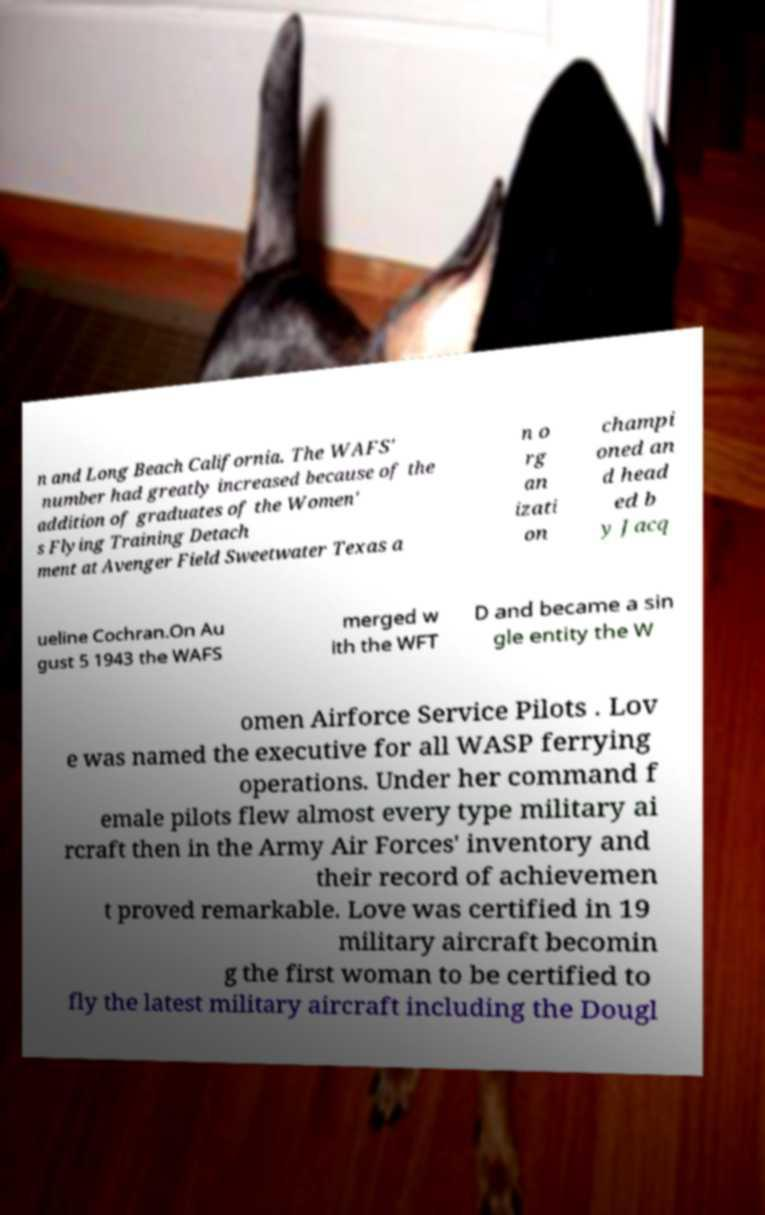There's text embedded in this image that I need extracted. Can you transcribe it verbatim? n and Long Beach California. The WAFS' number had greatly increased because of the addition of graduates of the Women' s Flying Training Detach ment at Avenger Field Sweetwater Texas a n o rg an izati on champi oned an d head ed b y Jacq ueline Cochran.On Au gust 5 1943 the WAFS merged w ith the WFT D and became a sin gle entity the W omen Airforce Service Pilots . Lov e was named the executive for all WASP ferrying operations. Under her command f emale pilots flew almost every type military ai rcraft then in the Army Air Forces' inventory and their record of achievemen t proved remarkable. Love was certified in 19 military aircraft becomin g the first woman to be certified to fly the latest military aircraft including the Dougl 